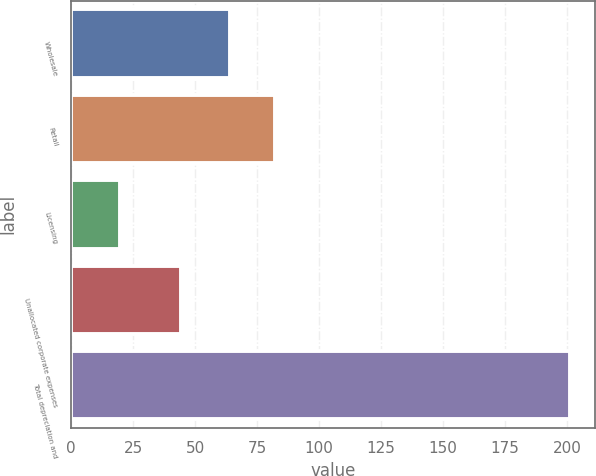Convert chart. <chart><loc_0><loc_0><loc_500><loc_500><bar_chart><fcel>Wholesale<fcel>Retail<fcel>Licensing<fcel>Unallocated corporate expenses<fcel>Total depreciation and<nl><fcel>63.9<fcel>82.06<fcel>19.7<fcel>44.3<fcel>201.3<nl></chart> 